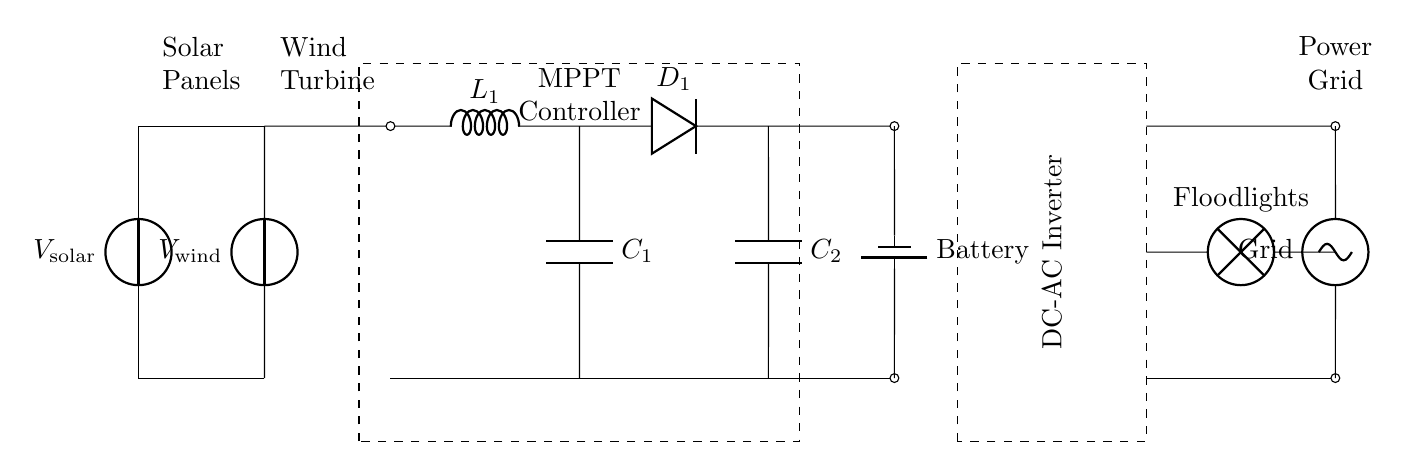What is the primary source of energy for the system? The circuit diagram shows both solar panels and a wind turbine contributing to the energy system; however, the primary source usually refers to the component designed to generate the most energy consistently. Since solar panels typically harness sunlight during the day, we can identify them as the primary source in most stadium environments.
Answer: Solar panels How many capacitors are in the circuit? By counting the symbols in the diagram, we identify two capacitor symbols labeled as C1 and C2. These capacitors serve to smooth out the voltage in the circuit, especially after the boost converter.
Answer: Two What component is used to convert DC to AC? The diagram illustrates a specific section with the label "DC-AC Inverter," indicating that it is responsible for converting the direct current produced by the solar panels and wind turbine into alternating current suitable for powering the floodlights.
Answer: DC-AC Inverter What is the role of the MPPT Controller? The MPPT (Maximum Power Point Tracking) Controller is depicted in a dashed rectangle in the circuit. Its function is to optimize the power output from the solar panels and wind turbine by adjusting the electrical operating point of the modules. By effectively managing the energy extraction, the MPPT ensures maximum efficiency in harnessing energy.
Answer: Optimize power output What is the purpose of the boost converter in this circuit? The boost converter in the circuit increases the voltage level from the solar panels and wind turbine to a higher voltage suitable for charging the battery and supplying the floodlights. By analyzing its position and connections, we identify its function as elevating the low voltage to fulfill the operational requirements of other components.
Answer: Increase voltage What does the battery store in the circuit? The battery is marked in the circuit and is essential for storing the electrical energy generated by the solar panels and wind turbine for later use. When the stadium lights are needed, the stored energy can be drawn from the battery, providing a reliable power supply independent of immediate generation.
Answer: Electrical energy How are the floodlights powered aside from the battery? The floodlights are also connected to the power grid, as shown in the circuit. The diagram demonstrates a dual connection where the floodlights can receive energy both from the battery and the grid, ensuring that they have a constant power supply during events.
Answer: Power grid 